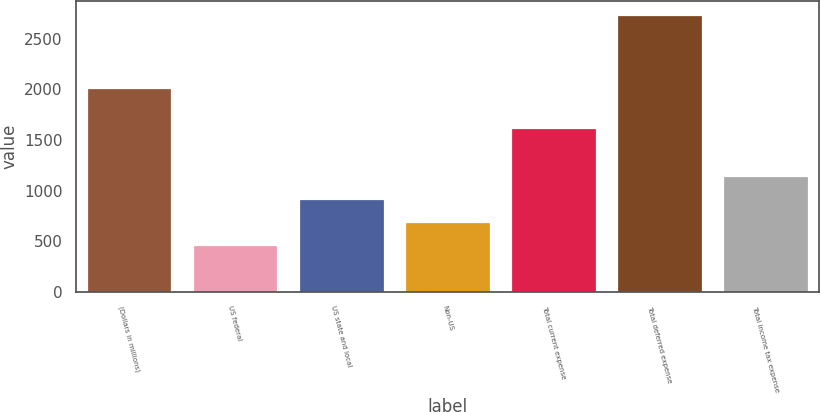Convert chart to OTSL. <chart><loc_0><loc_0><loc_500><loc_500><bar_chart><fcel>(Dollars in millions)<fcel>US federal<fcel>US state and local<fcel>Non-US<fcel>Total current expense<fcel>Total deferred expense<fcel>Total income tax expense<nl><fcel>2012<fcel>458<fcel>913.4<fcel>685.7<fcel>1619<fcel>2735<fcel>1141.1<nl></chart> 